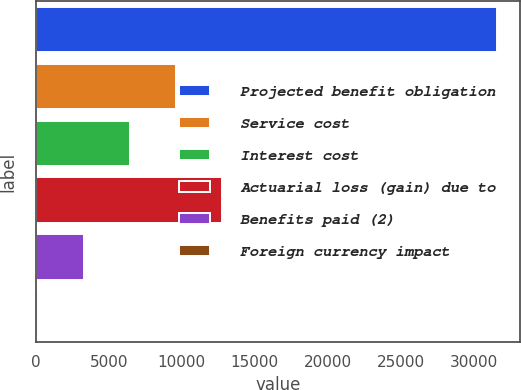<chart> <loc_0><loc_0><loc_500><loc_500><bar_chart><fcel>Projected benefit obligation<fcel>Service cost<fcel>Interest cost<fcel>Actuarial loss (gain) due to<fcel>Benefits paid (2)<fcel>Foreign currency impact<nl><fcel>31605<fcel>9607.5<fcel>6465<fcel>12750<fcel>3322.5<fcel>180<nl></chart> 